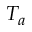<formula> <loc_0><loc_0><loc_500><loc_500>T _ { a }</formula> 